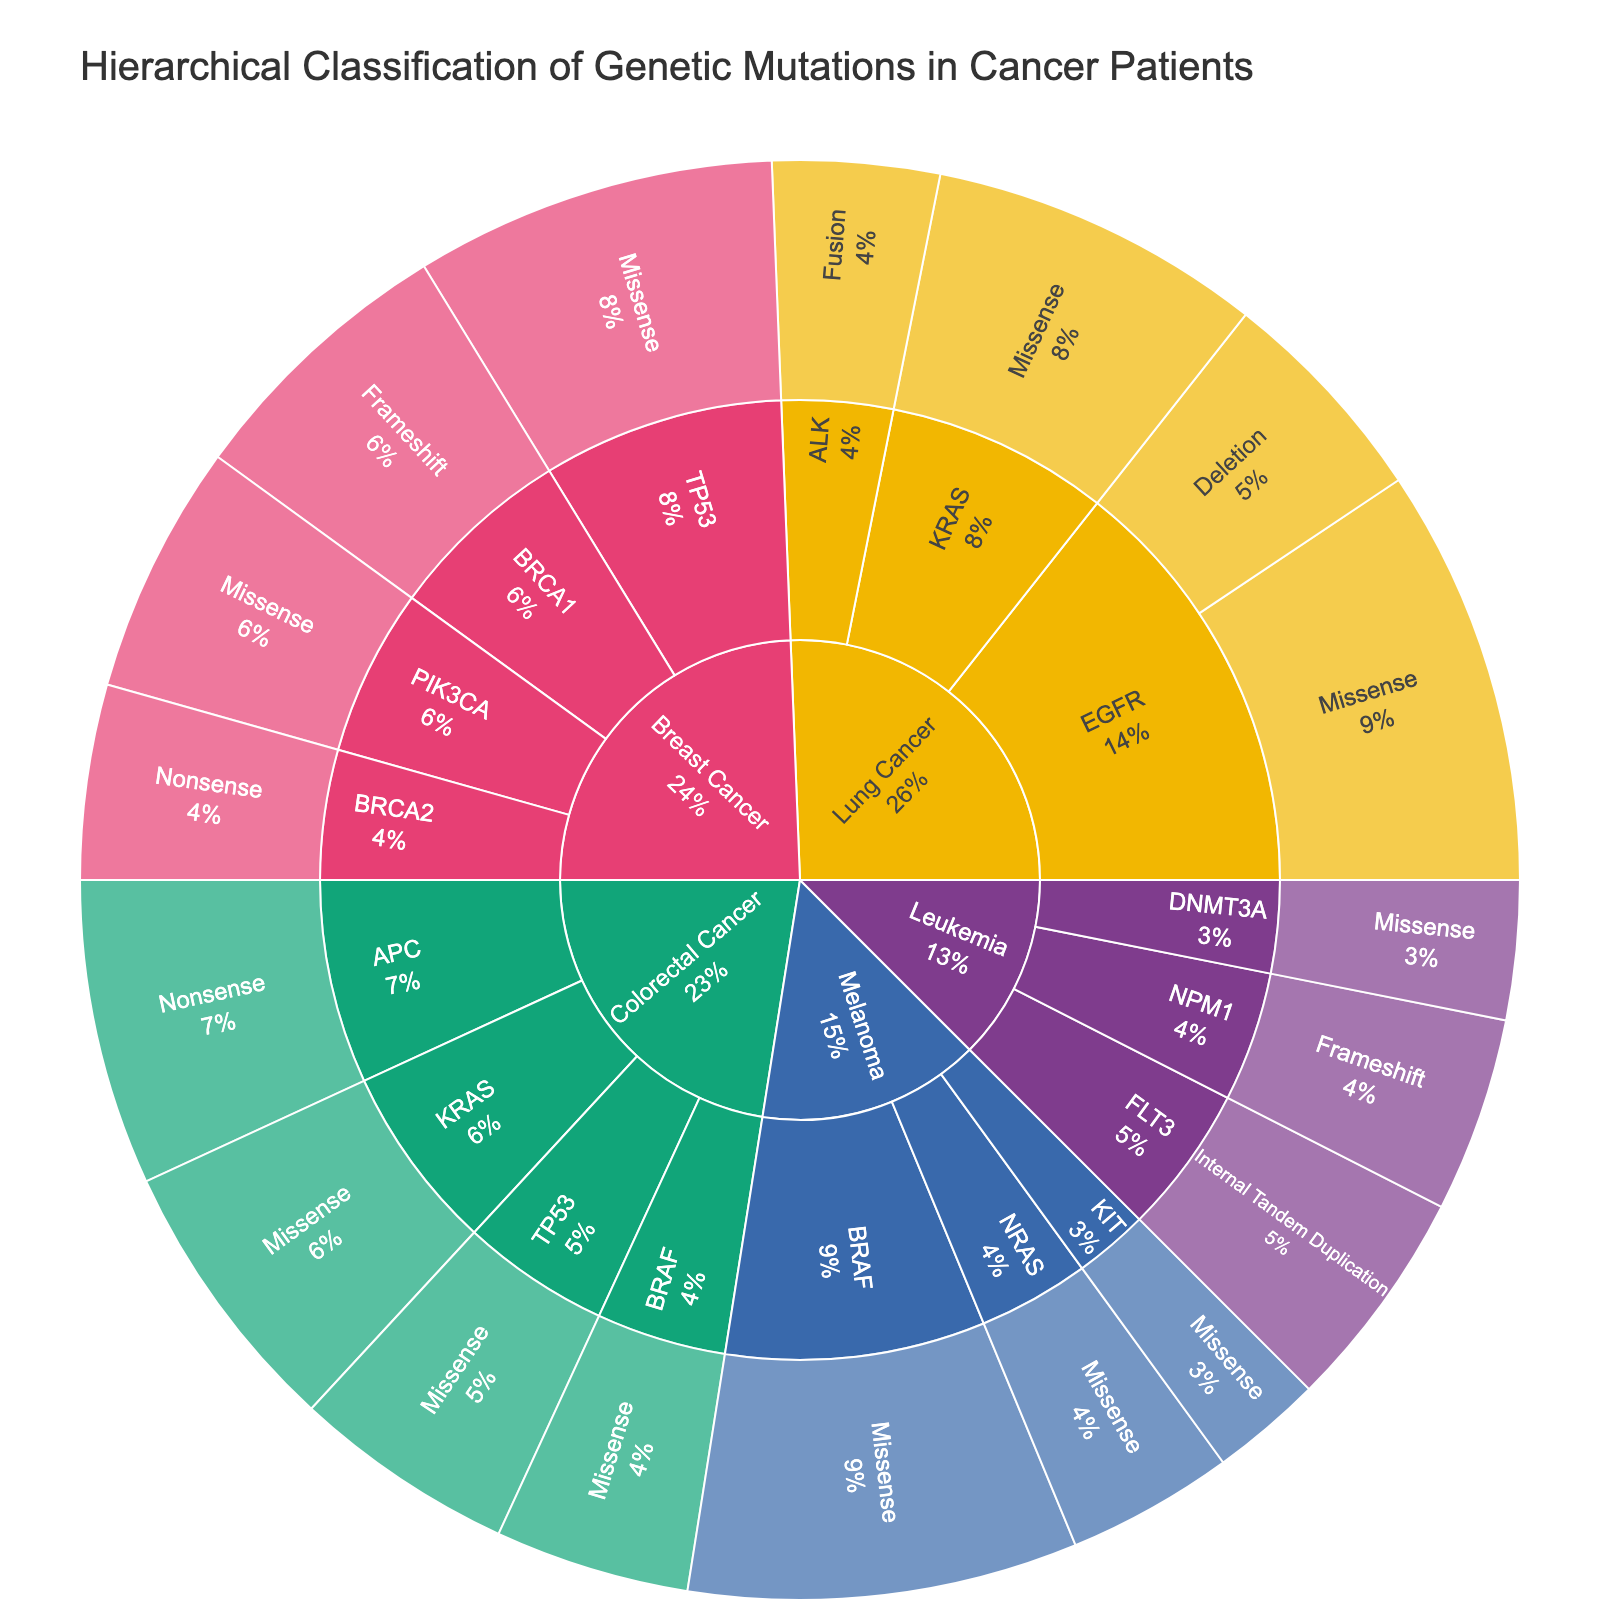What's the most common mutation type in Lung Cancer? Look at the sunburst plot for Lung Cancer and identify which mutation type has the largest section.
Answer: Missense Which cancer type has the highest number of genetic mutations? Observe the size of the segments for each cancer type in the sunburst plot. The largest segment represents the cancer type with the highest count.
Answer: Lung Cancer For Colorectal Cancer, which gene has more mutations: APC or KRAS? Compare the sizes of the segments for APC and KRAS under Colorectal Cancer. The larger segment indicates the gene with more mutations.
Answer: APC What is the total count of mutations for Breast Cancer? Sum the counts for all mutation types under Breast Cancer. 100 (BRCA1 Frameshift) + 70 (BRCA2 Nonsense) + 130 (TP53 Missense) + 90 (PIK3CA Missense) = 390
Answer: 390 Are Missense mutations more common in Melanoma or Lung Cancer? Compare the sizes of the Missense mutation segments for both Melanoma and Lung Cancer.
Answer: Lung Cancer Which gene in Leukemia has the fewest mutations? Identify the smallest segment under Leukemia.
Answer: DNMT3A In Breast Cancer, which has more mutations: BRCA1 Frameshift or PIK3CA Missense? Compare the sizes of the BRCA1 Frameshift and PIK3CA Missense segments.
Answer: BRCA1 Frameshift In the sunburst plot, what percentage of colorectal cancer mutations are TP53 Missense? Observe the percentage value shown on the TP53 Missense segment under Colorectal Cancer.
Answer: 80/360 = 22.2%, approximately 22% Which mutation type is exclusive to Leukemia in this plot? Identify which mutation type only appears under Leukemia.
Answer: Internal Tandem Duplication How do the missense mutations in KRAS compare between Lung Cancer and Colorectal Cancer? Look at the segments for KRAS Missense under both Lung Cancer and Colorectal Cancer and compare their sizes.
Answer: Lung Cancer has 120, Colorectal Cancer has 100 